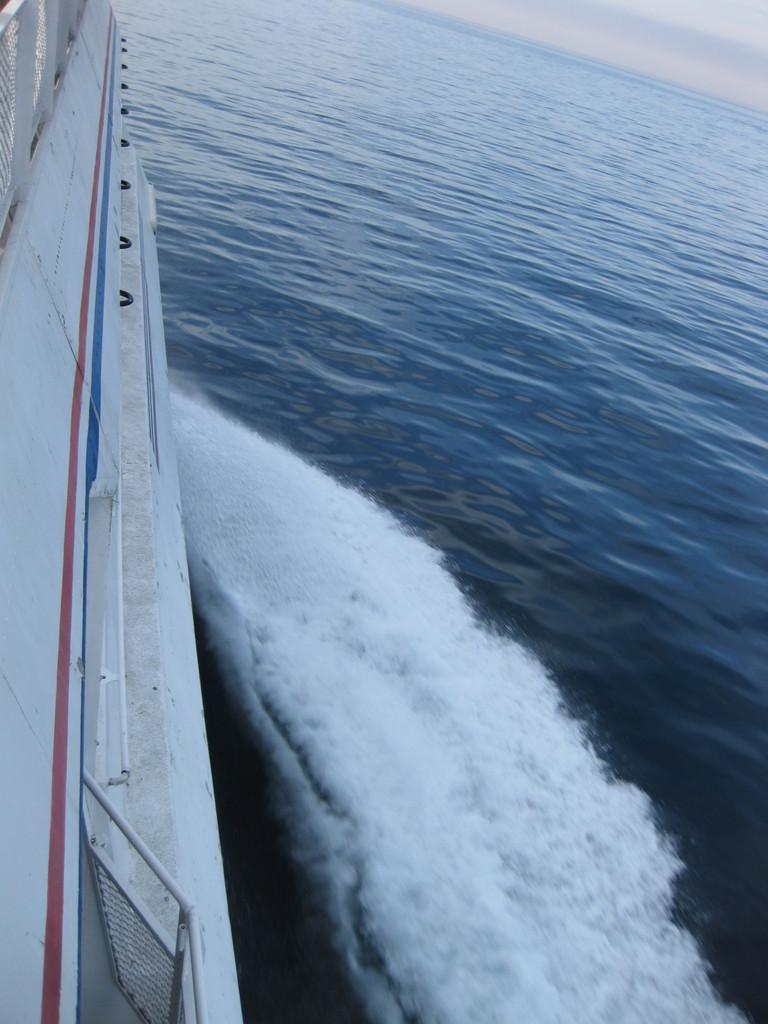Please provide a concise description of this image. In the image there is a ship going in the ocean and above its sky with clouds. 